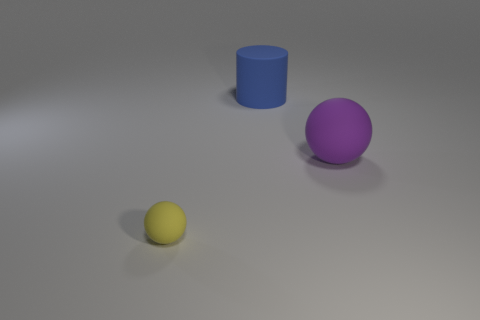There is a matte thing that is the same size as the cylinder; what color is it?
Offer a very short reply. Purple. What number of rubber objects are either purple balls or tiny yellow balls?
Make the answer very short. 2. What number of objects are both behind the tiny yellow matte thing and on the left side of the purple sphere?
Ensure brevity in your answer.  1. Is there anything else that has the same shape as the big purple object?
Provide a short and direct response. Yes. How many other objects are there of the same size as the blue matte cylinder?
Ensure brevity in your answer.  1. There is a ball that is to the right of the blue cylinder; is its size the same as the rubber object behind the big purple rubber thing?
Your answer should be very brief. Yes. How many objects are yellow matte balls or matte things on the right side of the tiny yellow matte object?
Provide a succinct answer. 3. How big is the object that is to the left of the blue cylinder?
Your response must be concise. Small. Is the number of large spheres that are left of the blue rubber object less than the number of big blue matte cylinders that are to the left of the yellow rubber ball?
Offer a terse response. No. The object that is in front of the blue cylinder and on the left side of the purple thing is made of what material?
Keep it short and to the point. Rubber. 